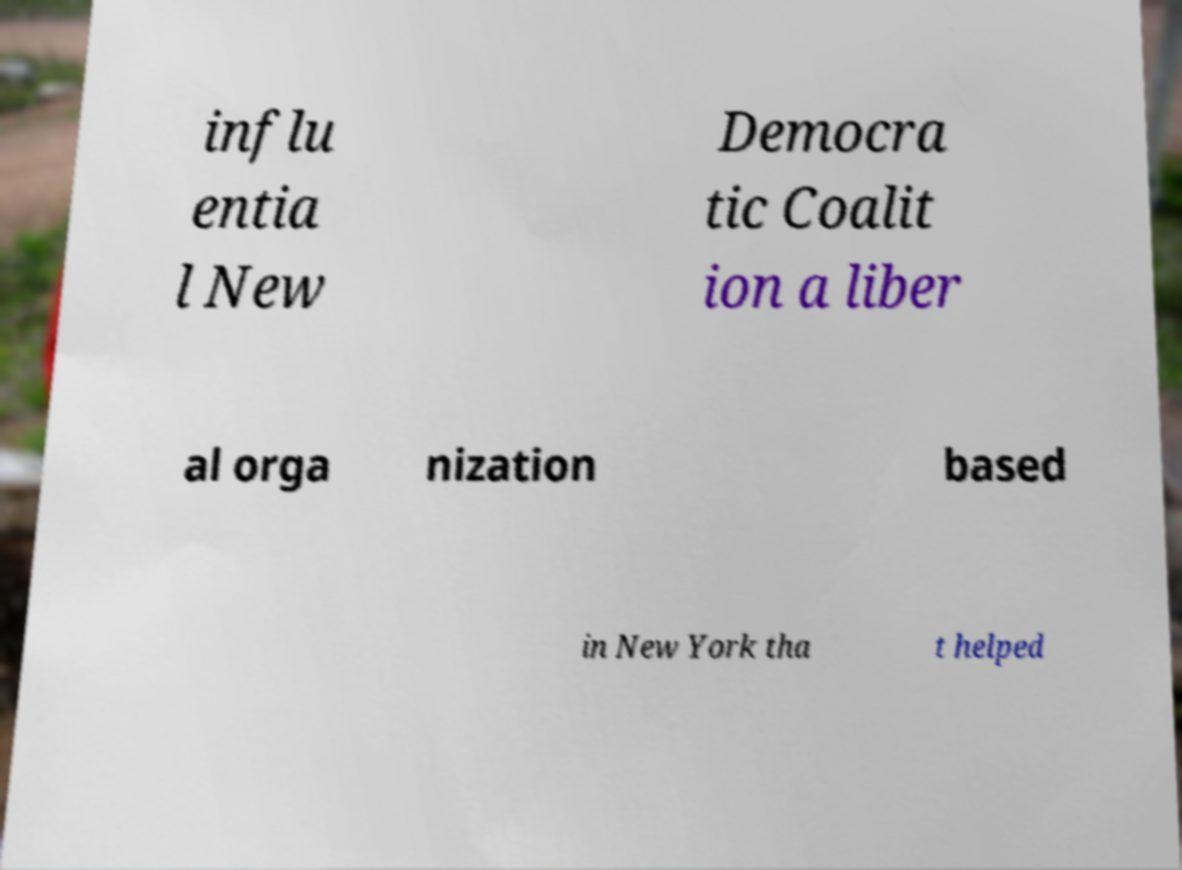Can you accurately transcribe the text from the provided image for me? influ entia l New Democra tic Coalit ion a liber al orga nization based in New York tha t helped 